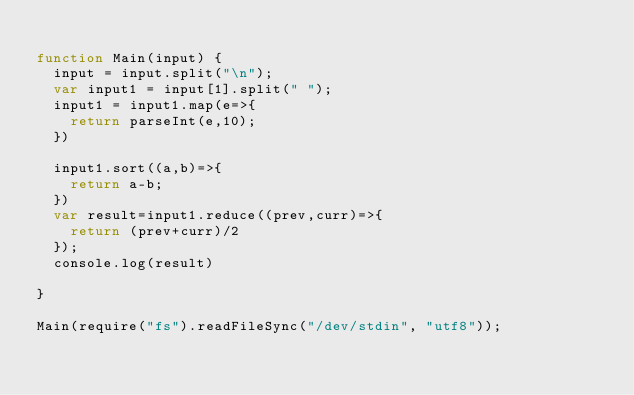Convert code to text. <code><loc_0><loc_0><loc_500><loc_500><_JavaScript_>
function Main(input) {
  input = input.split("\n");	
  var input1 = input[1].split(" ");	
  input1 = input1.map(e=>{
    return parseInt(e,10);
  })
  
  input1.sort((a,b)=>{
    return a-b;
  })
  var result=input1.reduce((prev,curr)=>{
    return (prev+curr)/2
  });
  console.log(result)
  
}

Main(require("fs").readFileSync("/dev/stdin", "utf8"));</code> 